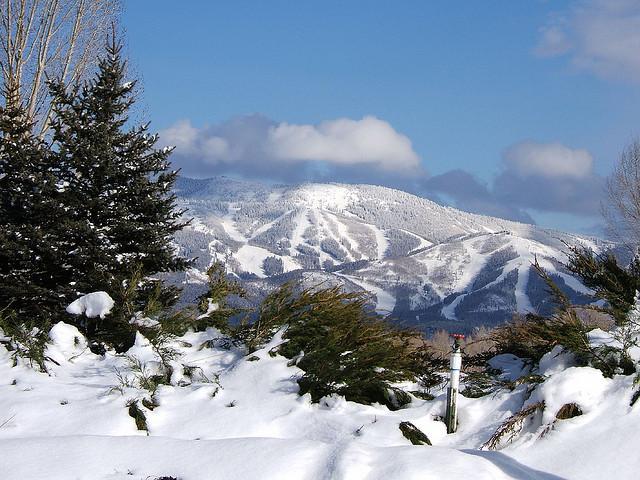Do you see any animals?
Give a very brief answer. No. Could people ski down this mountain?
Write a very short answer. No. How many signs are there?
Quick response, please. 0. Is it cloudy?
Keep it brief. Yes. What are the white stripes in the background?
Write a very short answer. Snow. 